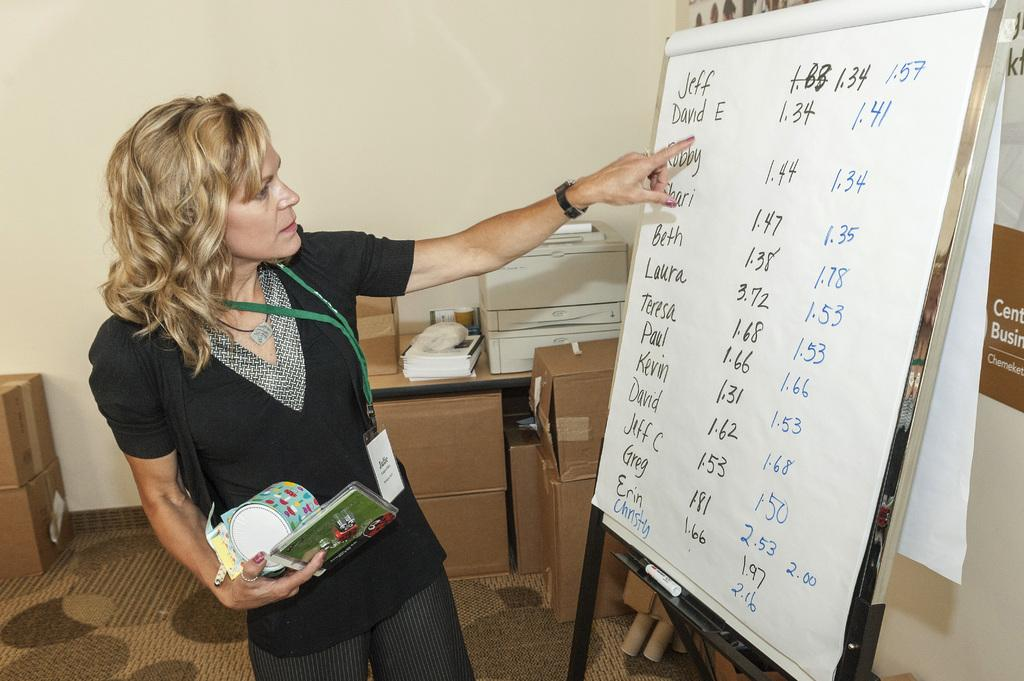<image>
Write a terse but informative summary of the picture. A woman points at David E's name on the list of names. 